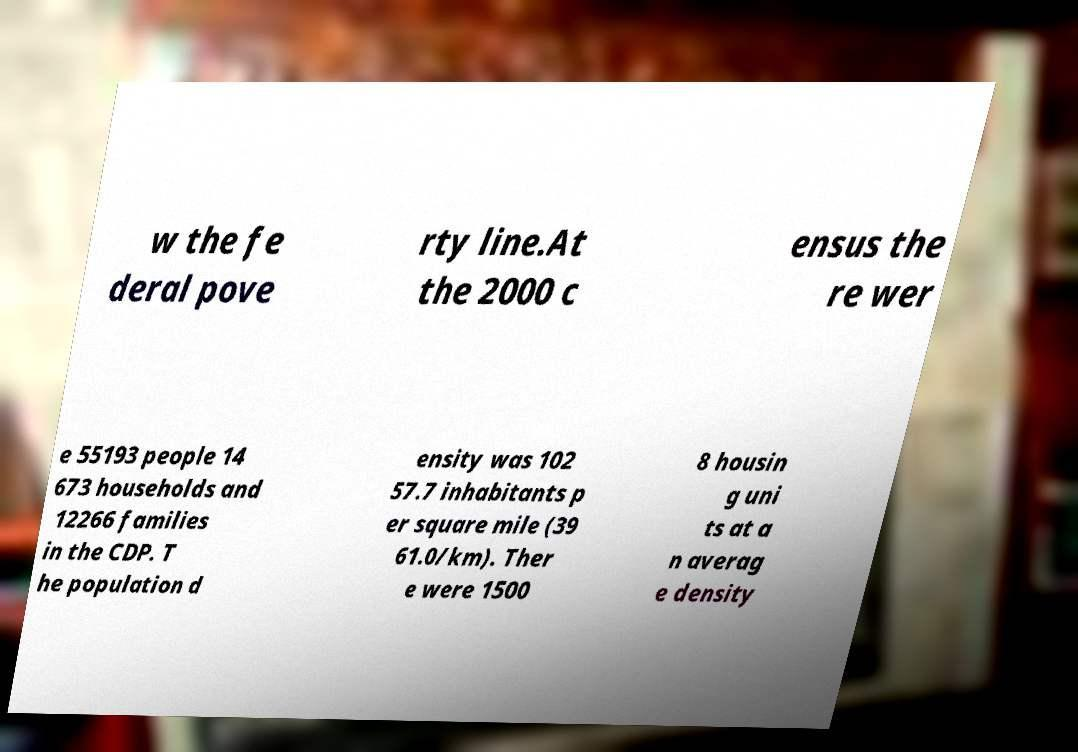For documentation purposes, I need the text within this image transcribed. Could you provide that? w the fe deral pove rty line.At the 2000 c ensus the re wer e 55193 people 14 673 households and 12266 families in the CDP. T he population d ensity was 102 57.7 inhabitants p er square mile (39 61.0/km). Ther e were 1500 8 housin g uni ts at a n averag e density 